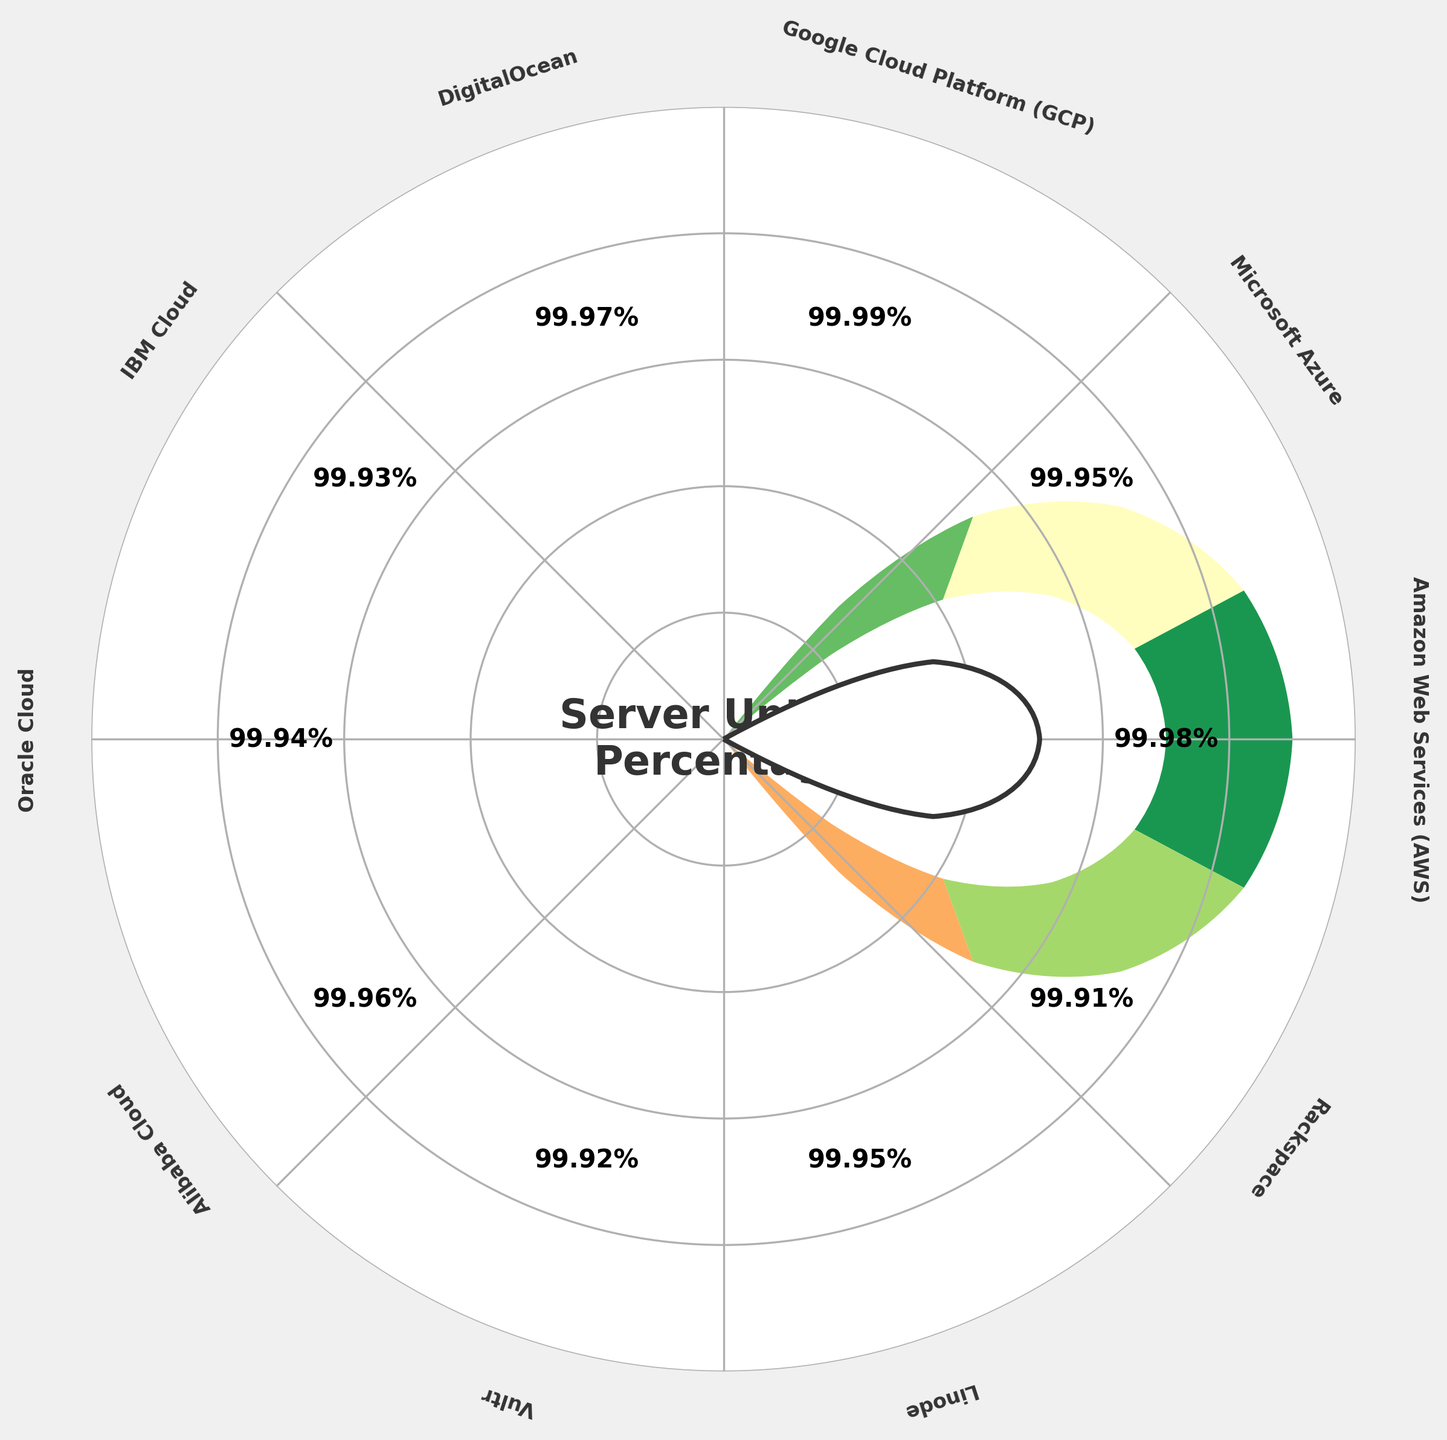Which cloud provider has the highest uptime percentage? Google Cloud Platform (GCP) has the highest uptime percentage at 99.99%, as seen on the gauge with the highest value.
Answer: Google Cloud Platform (GCP) Which cloud provider has the lowest uptime percentage? Rackspace has the lowest uptime percentage at 99.91%, as it is the smallest and located closest to the outer ring with the lowest value.
Answer: Rackspace How many cloud providers have an uptime percentage above 99.95? AWS (99.98), GCP (99.99), DigitalOcean (99.97), and Alibaba Cloud (99.96) are the four providers with uptime percentages above 99.95%.
Answer: 4 What's the difference in uptime percentage between the highest and the lowest providers? The difference between the highest (GCP at 99.99%) and the lowest (Rackspace at 99.91%) uptime percentages is 99.99 - 99.91 = 0.08%.
Answer: 0.08% Which providers have an uptime percentage equal to 99.95? Linode and Microsoft Azure have an uptime percentage of 99.95%, as their gauges are aligned with the 99.95% mark.
Answer: Linode, Microsoft Azure Between AWS and DigitalOcean, which provider has a higher uptime percentage? AWS has a higher uptime percentage (99.98%) compared to DigitalOcean (99.97%), based on their respective positions on the gauge chart.
Answer: AWS What's the average uptime percentage of AWS, Azure, and Google Cloud Platform? The average uptime percentage is (99.98 + 99.95 + 99.99) / 3 = 299.92 / 3 ≈ 99.97%.
Answer: 99.97% How many providers have a green-colored wedge in the gauge chart? Four providers have green-colored wedges indicating high uptime: AWS, GCP, DigitalOcean, and Alibaba Cloud.
Answer: 4 What's the median uptime percentage of all the cloud providers? The median is the middle value when sorted. The sorted values are 99.91, 99.92, 99.93, 99.94, 99.95, 99.95, 99.96, 99.97, 99.98, 99.99. The median is the average of the 5th and 6th values (99.95 and 99.95), so it is (99.95 + 99.95) / 2 = 99.95%.
Answer: 99.95% Are there more providers with uptime percentages above or below 99.94%? There are six providers above 99.94% (AWS, Azure, GCP, DigitalOcean, Oracle, and Alibaba) and four below (IBM, Vultr, Linode, Rackspace).
Answer: Above How many different colors are used in the wedge representation? Three colors are used, representing different uptime ranges: red for low, yellow for moderate, and green for high uptime percentages.
Answer: 3 